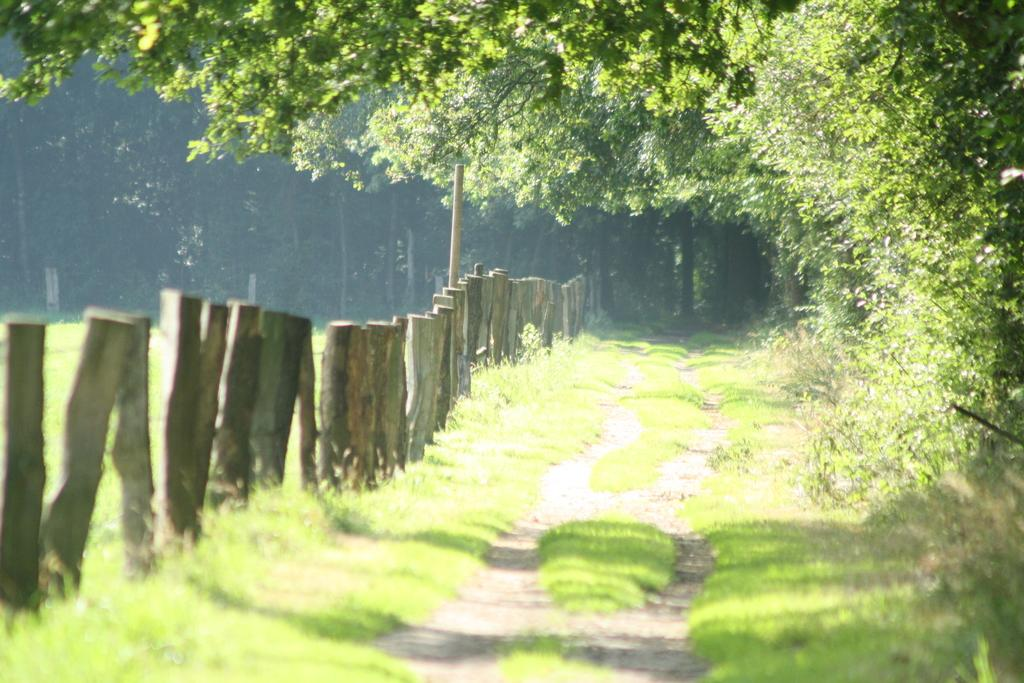What type of environment is depicted in the image? The image is an outside view. What is covering the ground in the image? There is grass on the ground in the image. What can be seen on the left side of the image? There are poles on the left side of the image. What is visible in the distance in the image? There are many trees in the background of the image. What type of brick is used to build the seat in the image? There is no seat present in the image, so it is not possible to determine the type of brick used. 